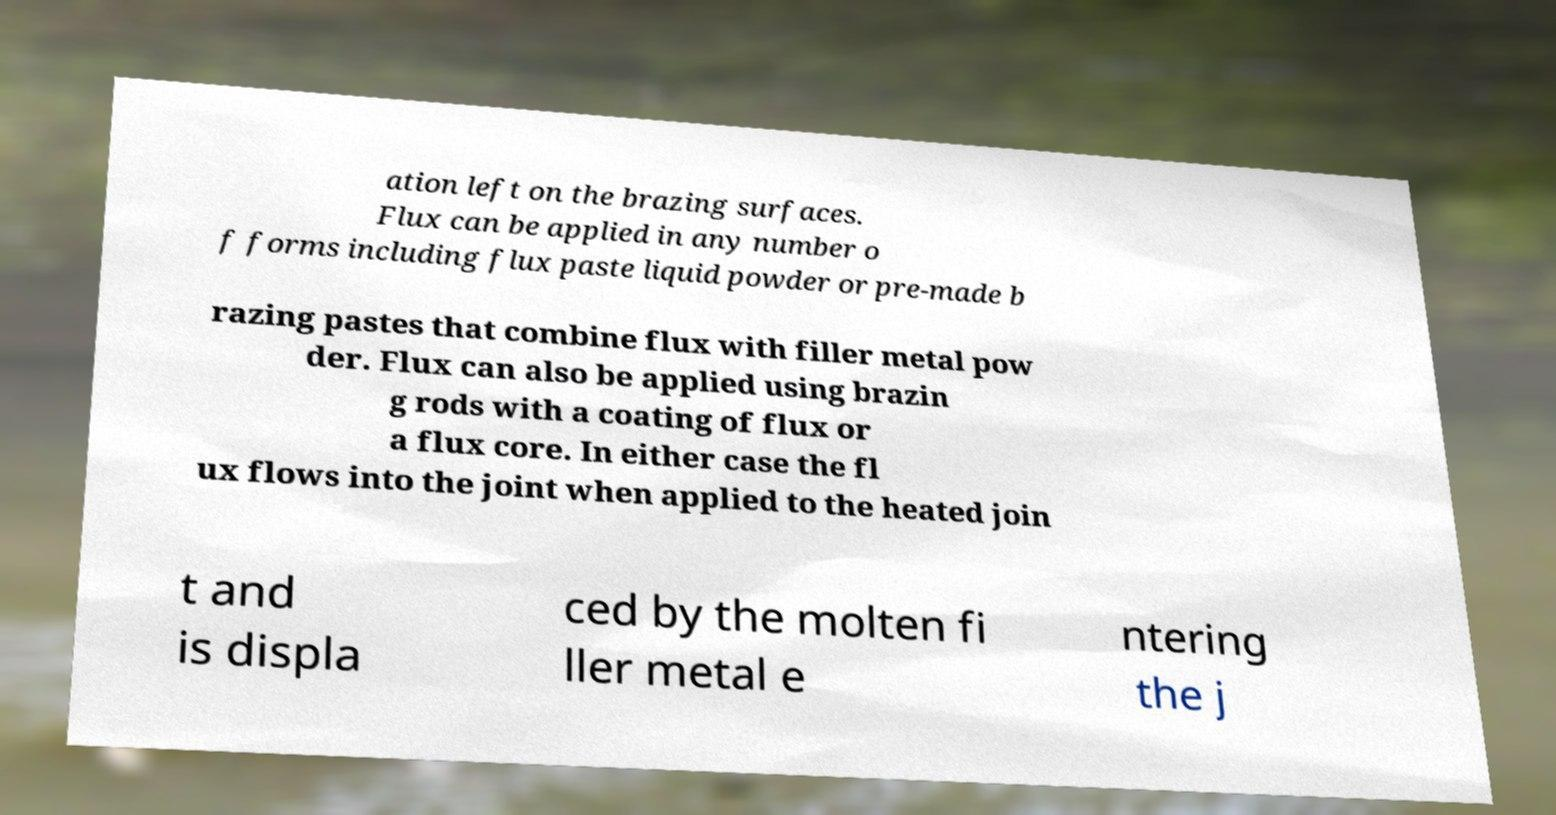There's text embedded in this image that I need extracted. Can you transcribe it verbatim? ation left on the brazing surfaces. Flux can be applied in any number o f forms including flux paste liquid powder or pre-made b razing pastes that combine flux with filler metal pow der. Flux can also be applied using brazin g rods with a coating of flux or a flux core. In either case the fl ux flows into the joint when applied to the heated join t and is displa ced by the molten fi ller metal e ntering the j 